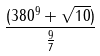<formula> <loc_0><loc_0><loc_500><loc_500>\frac { ( 3 8 0 ^ { 9 } + \sqrt { 1 0 } ) } { \frac { 9 } { 7 } }</formula> 